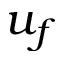Convert formula to latex. <formula><loc_0><loc_0><loc_500><loc_500>u _ { f }</formula> 